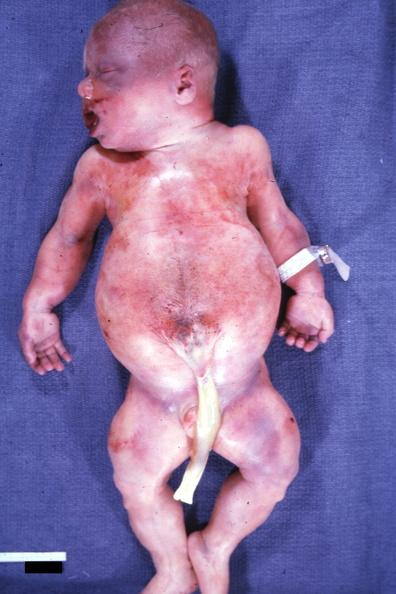what are slide?
Answer the question using a single word or phrase. This whole body photo showing widened abdomen due to diastasis recti and crease in ear lobe face is and kidneys with bilateral pelvic-ureteral strictures 